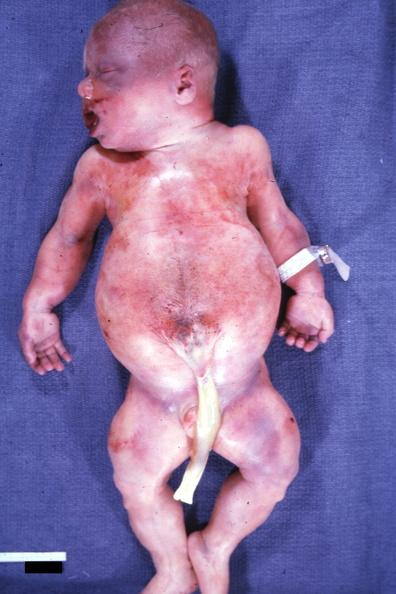what are slide?
Answer the question using a single word or phrase. This whole body photo showing widened abdomen due to diastasis recti and crease in ear lobe face is and kidneys with bilateral pelvic-ureteral strictures 